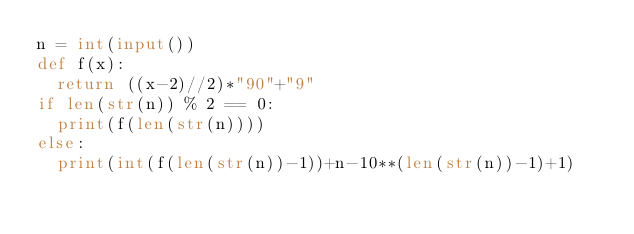<code> <loc_0><loc_0><loc_500><loc_500><_Python_>n = int(input())
def f(x):
  return ((x-2)//2)*"90"+"9"
if len(str(n)) % 2 == 0:
  print(f(len(str(n))))
else:
  print(int(f(len(str(n))-1))+n-10**(len(str(n))-1)+1)</code> 